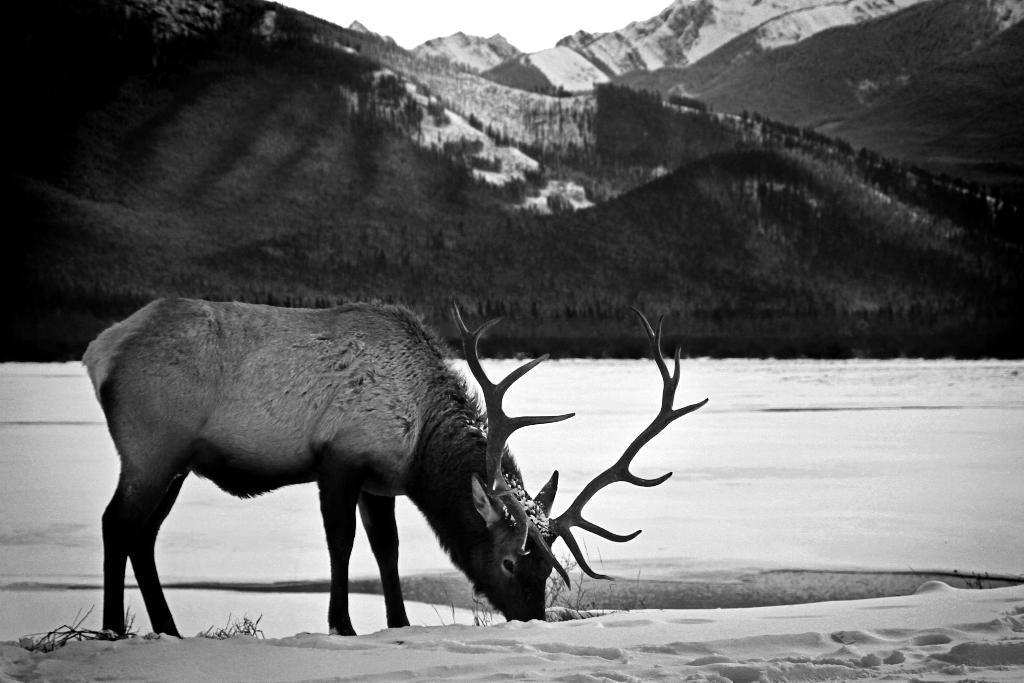In one or two sentences, can you explain what this image depicts? Here in this picture we can see a reindeer present on the ground, which is fully covered with snow over there and behind it we can see mountains, fully covered with grass and snow all over there. 